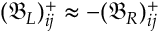Convert formula to latex. <formula><loc_0><loc_0><loc_500><loc_500>( \mathfrak { B } _ { L } ) _ { i j } ^ { + } \approx - ( \mathfrak { B } _ { R } ) _ { i j } ^ { + }</formula> 